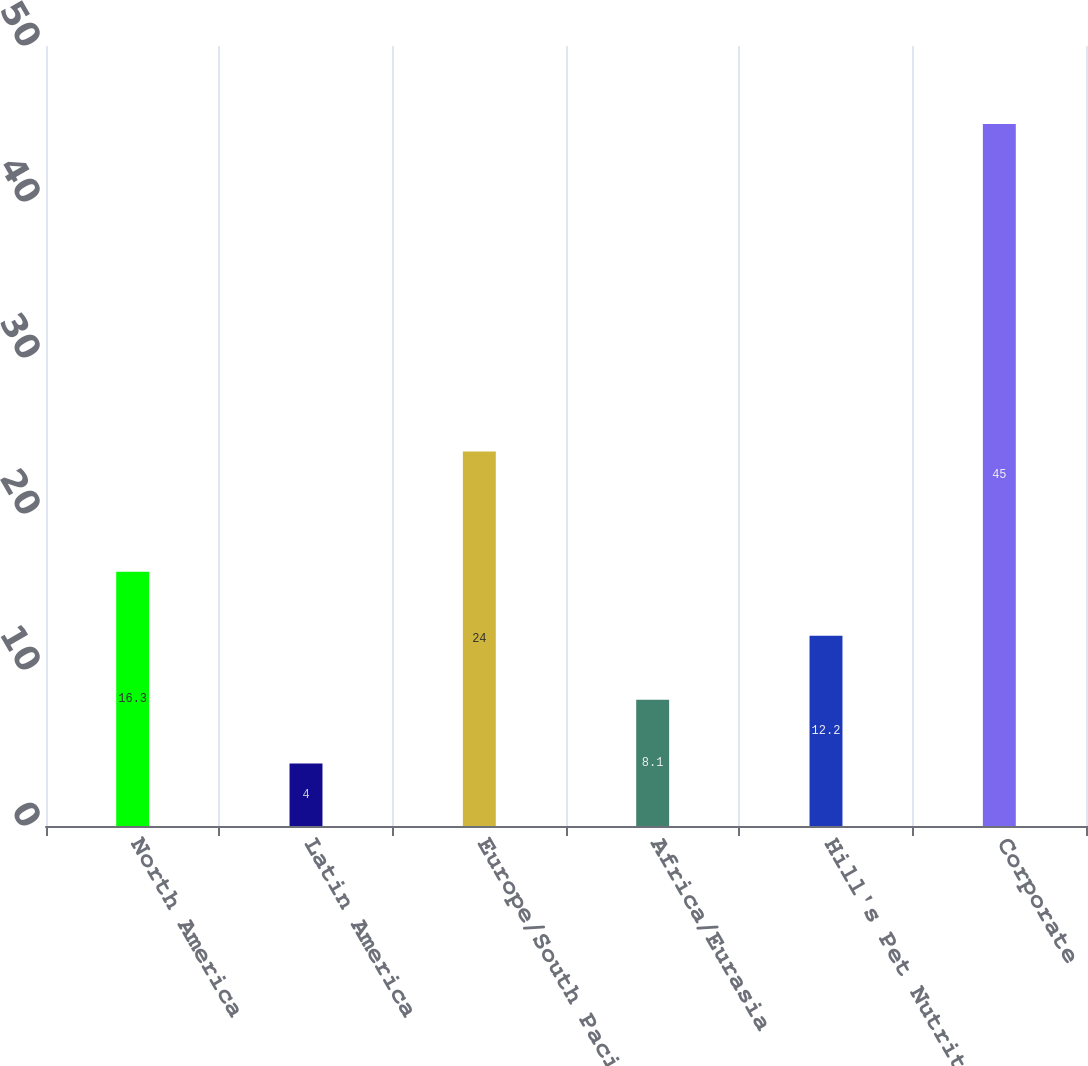Convert chart to OTSL. <chart><loc_0><loc_0><loc_500><loc_500><bar_chart><fcel>North America<fcel>Latin America<fcel>Europe/South Pacific<fcel>Africa/Eurasia<fcel>Hill's Pet Nutrition<fcel>Corporate<nl><fcel>16.3<fcel>4<fcel>24<fcel>8.1<fcel>12.2<fcel>45<nl></chart> 